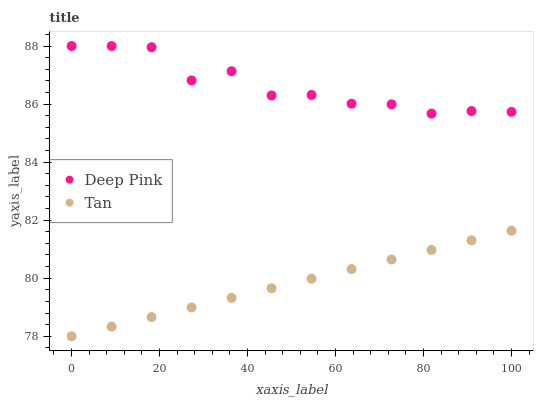Does Tan have the minimum area under the curve?
Answer yes or no. Yes. Does Deep Pink have the maximum area under the curve?
Answer yes or no. Yes. Does Deep Pink have the minimum area under the curve?
Answer yes or no. No. Is Tan the smoothest?
Answer yes or no. Yes. Is Deep Pink the roughest?
Answer yes or no. Yes. Is Deep Pink the smoothest?
Answer yes or no. No. Does Tan have the lowest value?
Answer yes or no. Yes. Does Deep Pink have the lowest value?
Answer yes or no. No. Does Deep Pink have the highest value?
Answer yes or no. Yes. Is Tan less than Deep Pink?
Answer yes or no. Yes. Is Deep Pink greater than Tan?
Answer yes or no. Yes. Does Tan intersect Deep Pink?
Answer yes or no. No. 